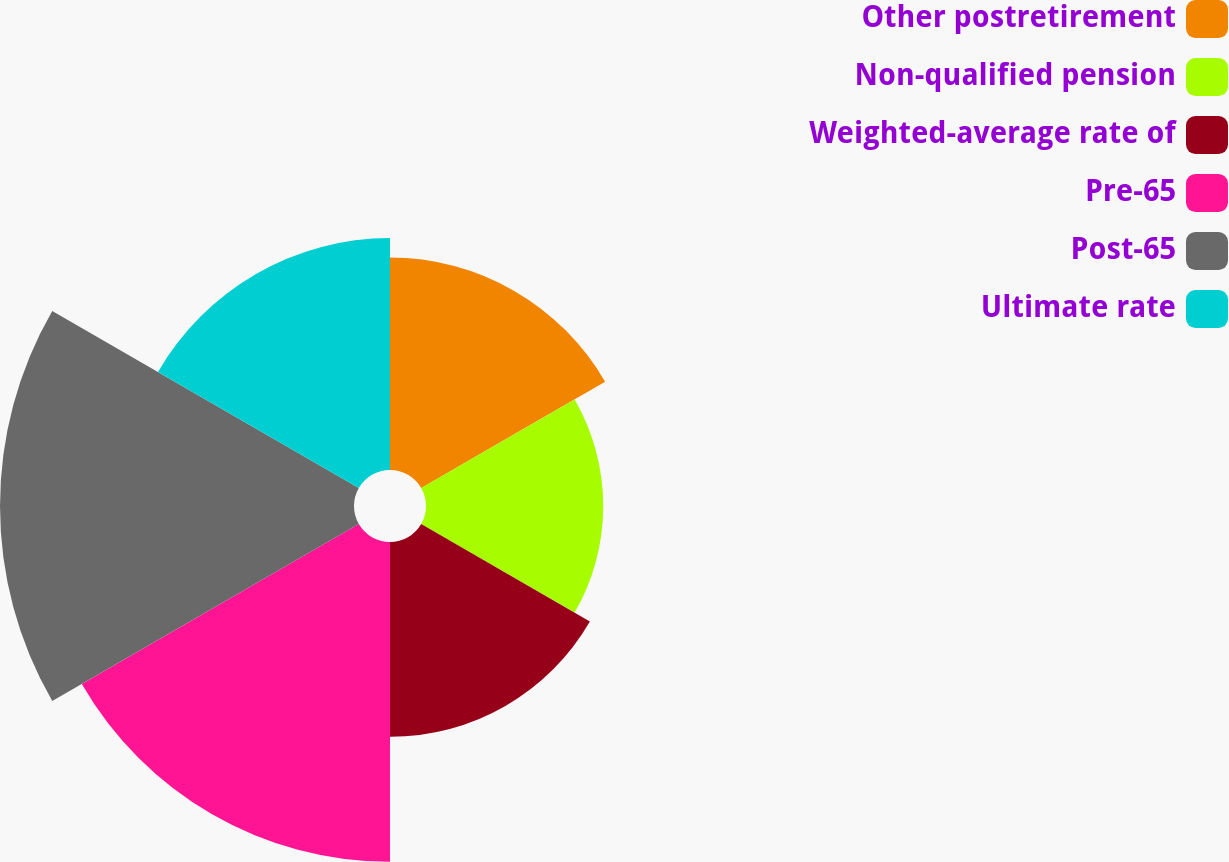<chart> <loc_0><loc_0><loc_500><loc_500><pie_chart><fcel>Other postretirement<fcel>Non-qualified pension<fcel>Weighted-average rate of<fcel>Pre-65<fcel>Post-65<fcel>Ultimate rate<nl><fcel>14.25%<fcel>11.89%<fcel>13.07%<fcel>21.46%<fcel>23.75%<fcel>15.56%<nl></chart> 